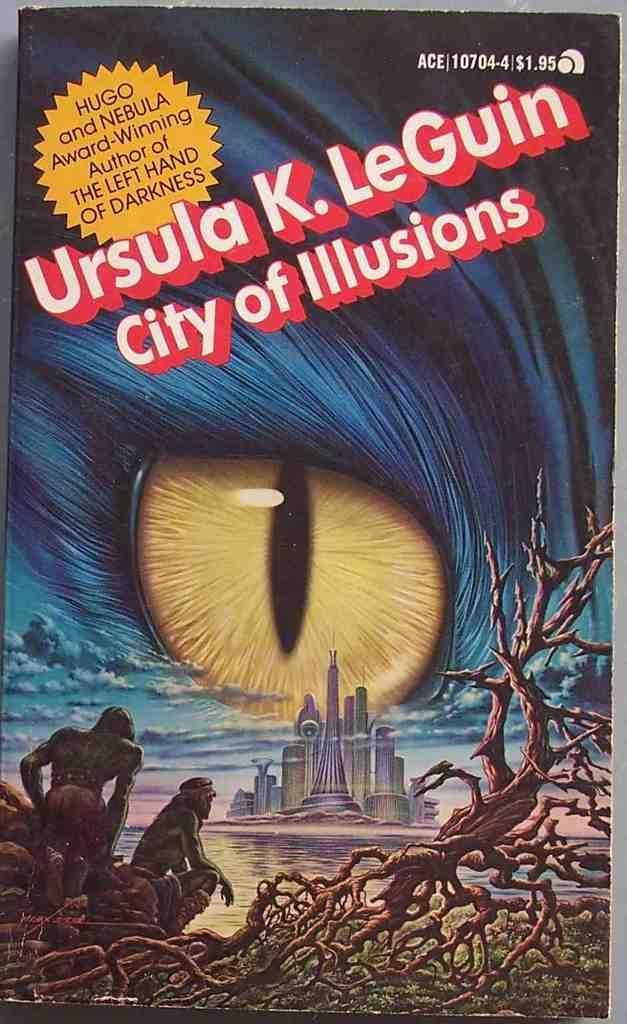What is the main subject of the poster in the image? The poster contains an image of an eye. What other images are present on the poster? The poster contains images of people, a building, and a trunk. Is there any text on the poster? Yes, there is text written on the poster. How many minutes does it take for the edge of the poster to become visible in the image? There is no information about the edge of the poster or any time-related aspect in the image, so this question cannot be answered definitively. 